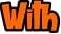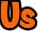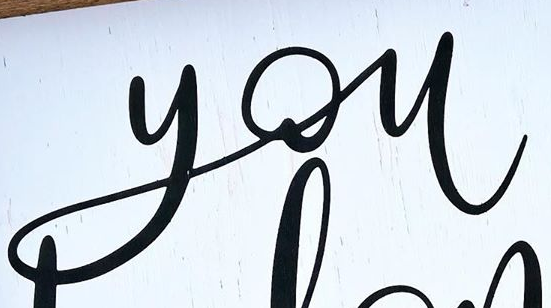What text is displayed in these images sequentially, separated by a semicolon? With; Us; you 